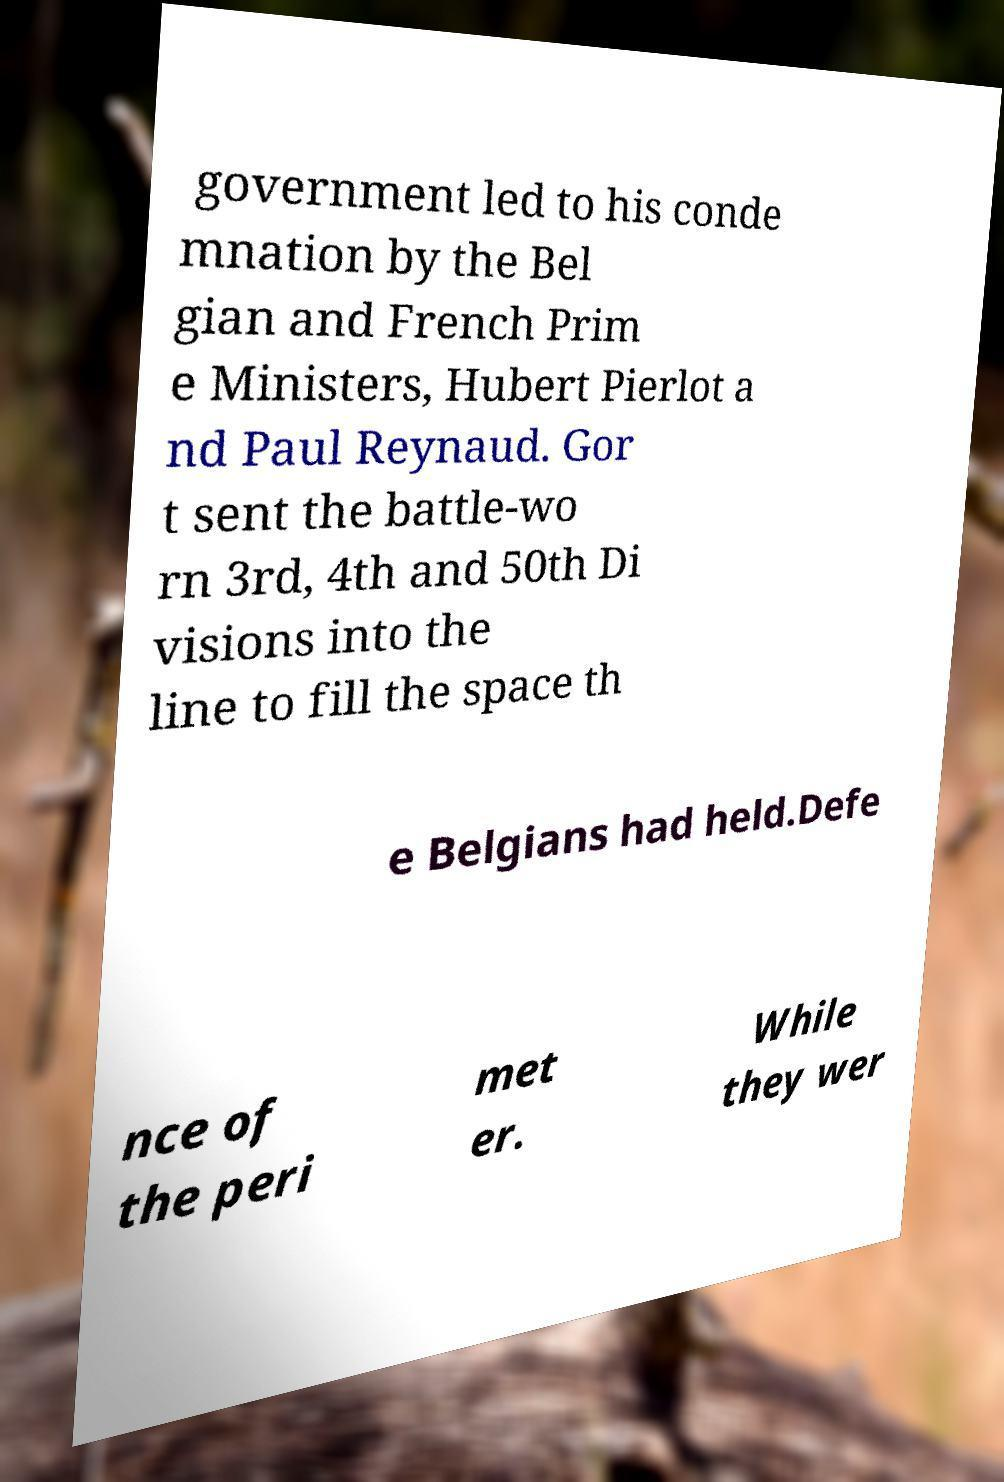What messages or text are displayed in this image? I need them in a readable, typed format. government led to his conde mnation by the Bel gian and French Prim e Ministers, Hubert Pierlot a nd Paul Reynaud. Gor t sent the battle-wo rn 3rd, 4th and 50th Di visions into the line to fill the space th e Belgians had held.Defe nce of the peri met er. While they wer 